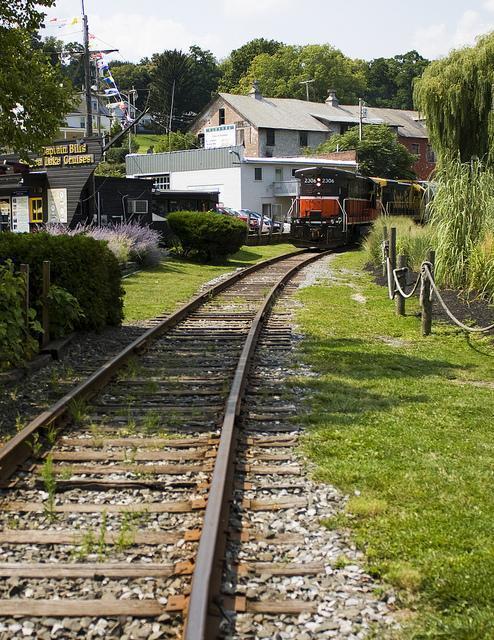What color is the lateral stripe around the train engine?
Indicate the correct response by choosing from the four available options to answer the question.
Options: White, blue, red, green. Red. 